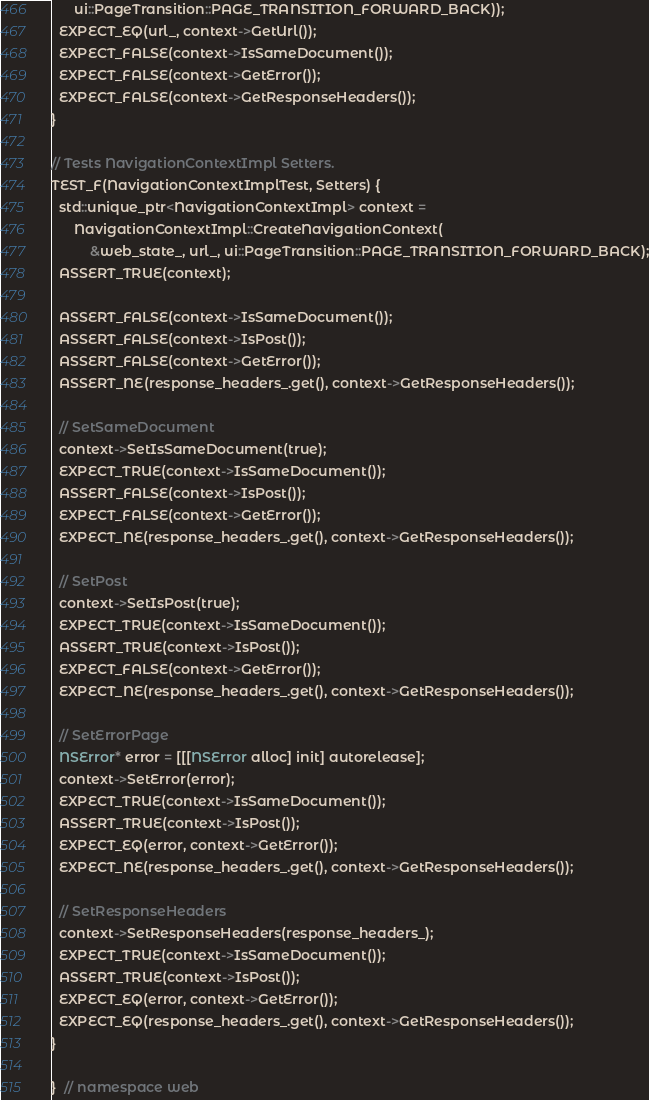Convert code to text. <code><loc_0><loc_0><loc_500><loc_500><_ObjectiveC_>      ui::PageTransition::PAGE_TRANSITION_FORWARD_BACK));
  EXPECT_EQ(url_, context->GetUrl());
  EXPECT_FALSE(context->IsSameDocument());
  EXPECT_FALSE(context->GetError());
  EXPECT_FALSE(context->GetResponseHeaders());
}

// Tests NavigationContextImpl Setters.
TEST_F(NavigationContextImplTest, Setters) {
  std::unique_ptr<NavigationContextImpl> context =
      NavigationContextImpl::CreateNavigationContext(
          &web_state_, url_, ui::PageTransition::PAGE_TRANSITION_FORWARD_BACK);
  ASSERT_TRUE(context);

  ASSERT_FALSE(context->IsSameDocument());
  ASSERT_FALSE(context->IsPost());
  ASSERT_FALSE(context->GetError());
  ASSERT_NE(response_headers_.get(), context->GetResponseHeaders());

  // SetSameDocument
  context->SetIsSameDocument(true);
  EXPECT_TRUE(context->IsSameDocument());
  ASSERT_FALSE(context->IsPost());
  EXPECT_FALSE(context->GetError());
  EXPECT_NE(response_headers_.get(), context->GetResponseHeaders());

  // SetPost
  context->SetIsPost(true);
  EXPECT_TRUE(context->IsSameDocument());
  ASSERT_TRUE(context->IsPost());
  EXPECT_FALSE(context->GetError());
  EXPECT_NE(response_headers_.get(), context->GetResponseHeaders());

  // SetErrorPage
  NSError* error = [[[NSError alloc] init] autorelease];
  context->SetError(error);
  EXPECT_TRUE(context->IsSameDocument());
  ASSERT_TRUE(context->IsPost());
  EXPECT_EQ(error, context->GetError());
  EXPECT_NE(response_headers_.get(), context->GetResponseHeaders());

  // SetResponseHeaders
  context->SetResponseHeaders(response_headers_);
  EXPECT_TRUE(context->IsSameDocument());
  ASSERT_TRUE(context->IsPost());
  EXPECT_EQ(error, context->GetError());
  EXPECT_EQ(response_headers_.get(), context->GetResponseHeaders());
}

}  // namespace web
</code> 